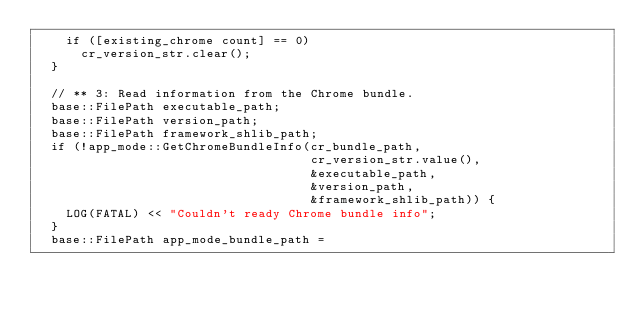<code> <loc_0><loc_0><loc_500><loc_500><_ObjectiveC_>    if ([existing_chrome count] == 0)
      cr_version_str.clear();
  }

  // ** 3: Read information from the Chrome bundle.
  base::FilePath executable_path;
  base::FilePath version_path;
  base::FilePath framework_shlib_path;
  if (!app_mode::GetChromeBundleInfo(cr_bundle_path,
                                     cr_version_str.value(),
                                     &executable_path,
                                     &version_path,
                                     &framework_shlib_path)) {
    LOG(FATAL) << "Couldn't ready Chrome bundle info";
  }
  base::FilePath app_mode_bundle_path =</code> 